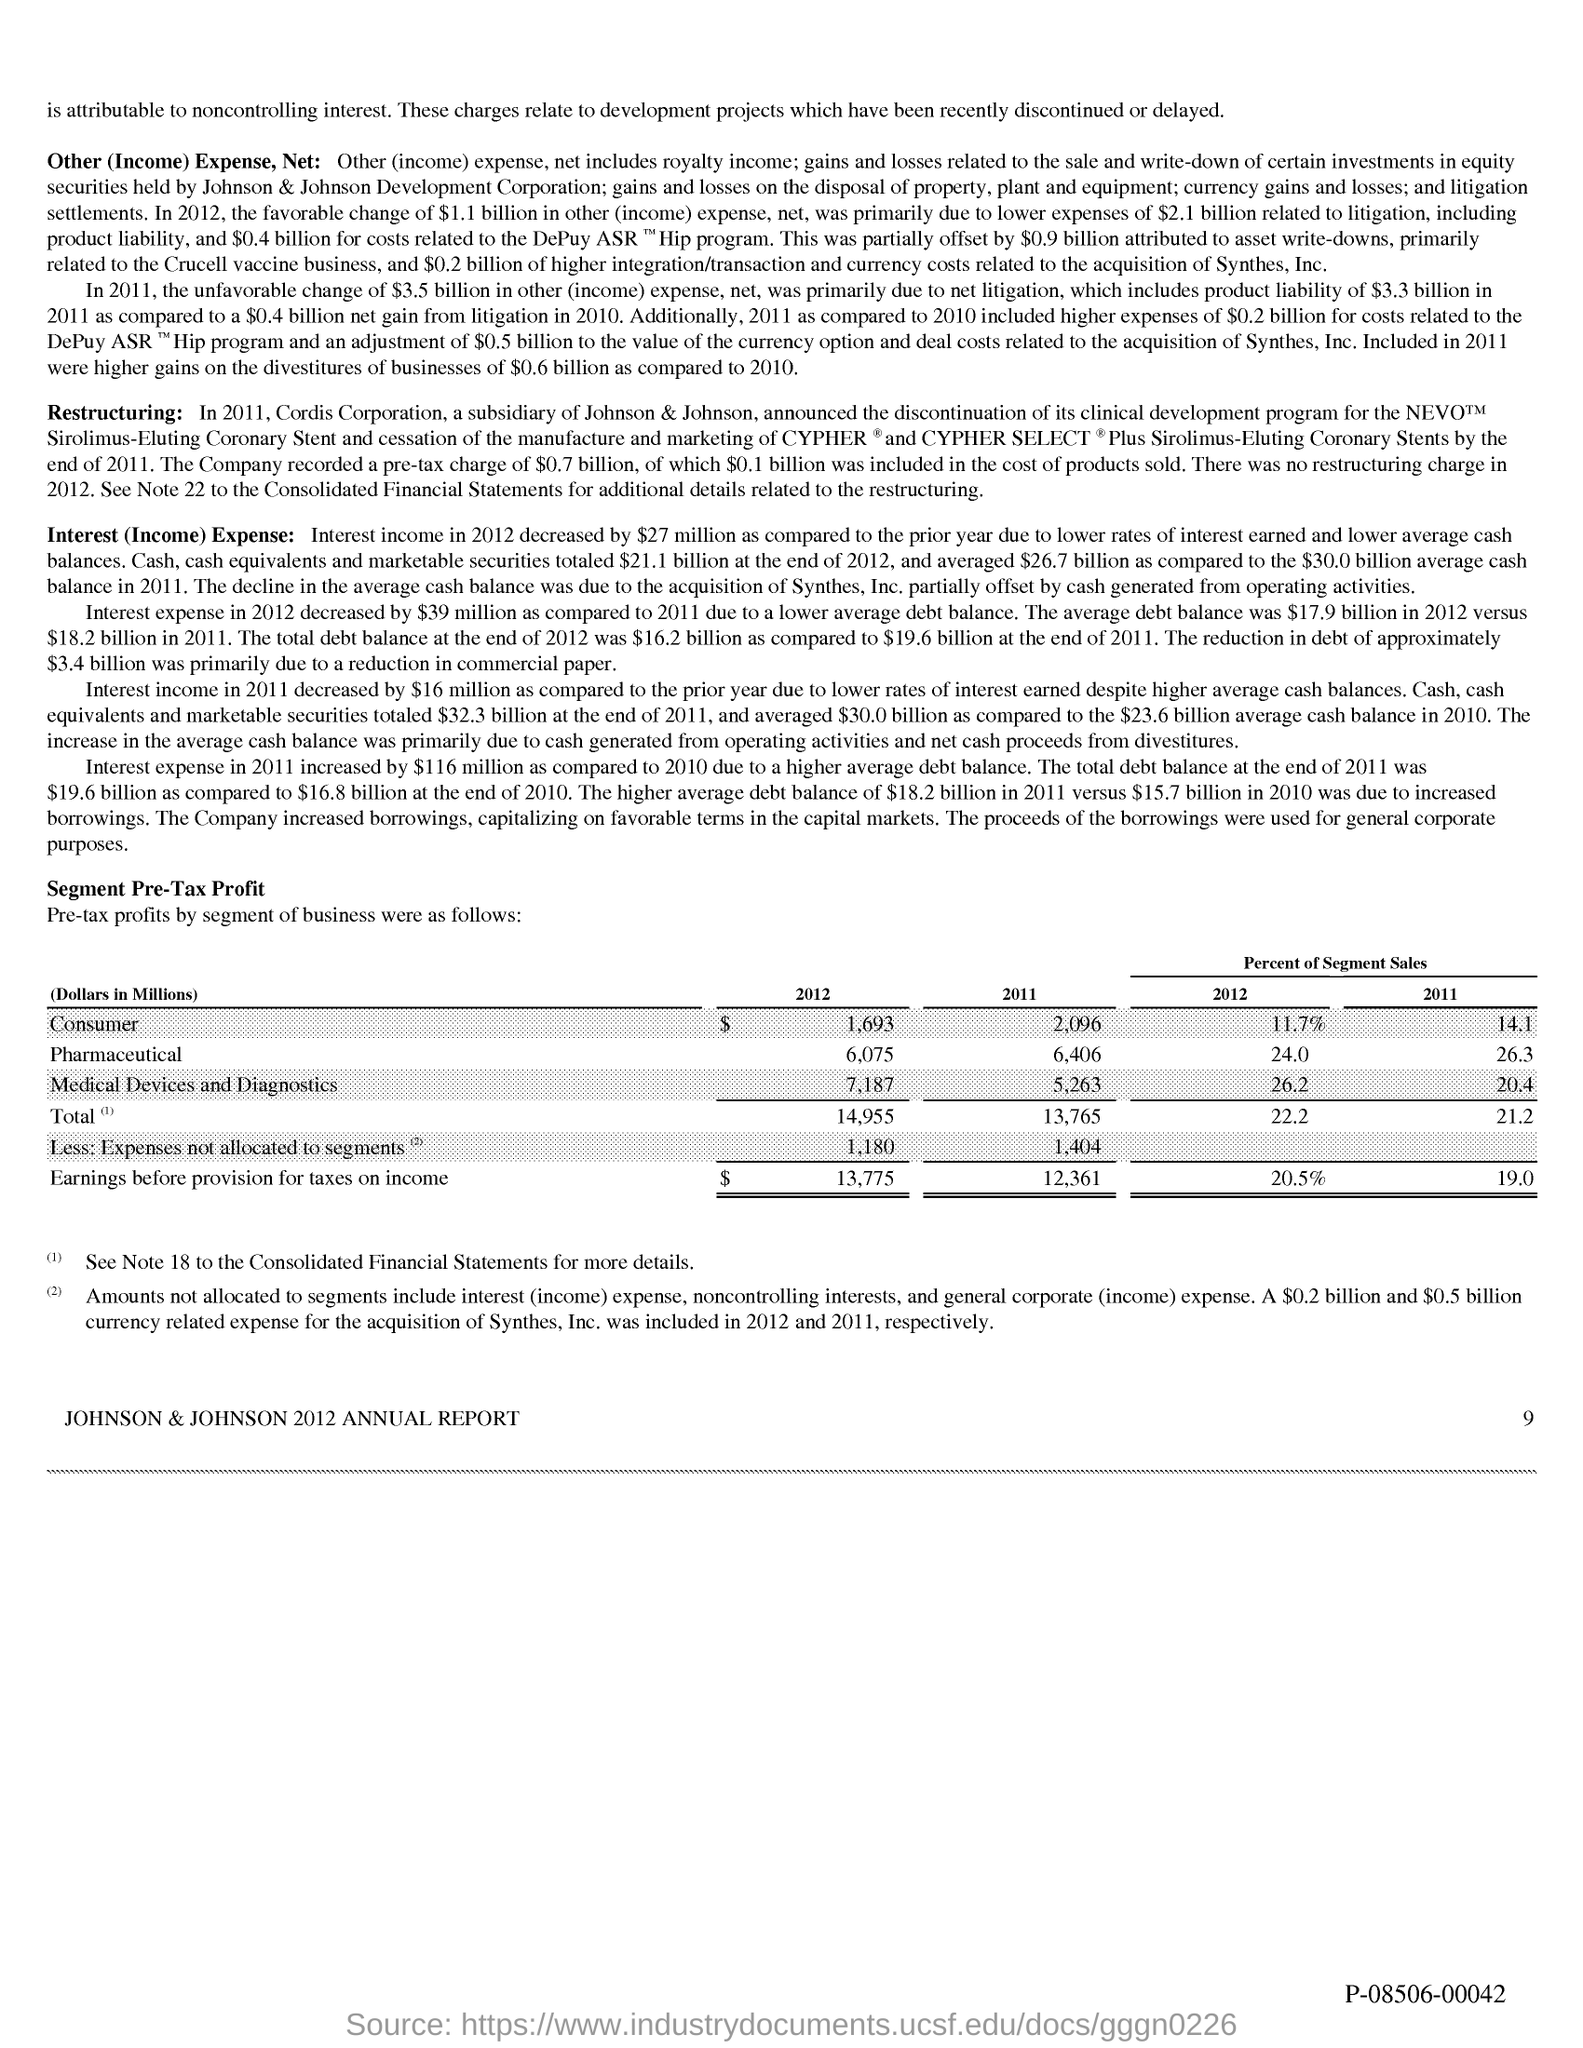Mention a couple of crucial points in this snapshot. The page number is 9. 